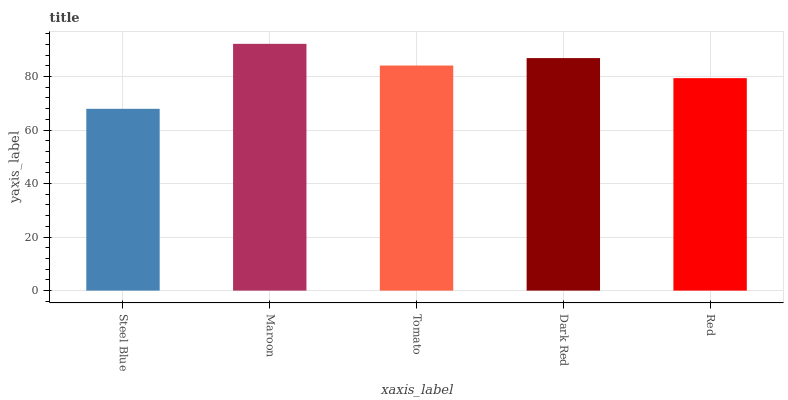Is Steel Blue the minimum?
Answer yes or no. Yes. Is Maroon the maximum?
Answer yes or no. Yes. Is Tomato the minimum?
Answer yes or no. No. Is Tomato the maximum?
Answer yes or no. No. Is Maroon greater than Tomato?
Answer yes or no. Yes. Is Tomato less than Maroon?
Answer yes or no. Yes. Is Tomato greater than Maroon?
Answer yes or no. No. Is Maroon less than Tomato?
Answer yes or no. No. Is Tomato the high median?
Answer yes or no. Yes. Is Tomato the low median?
Answer yes or no. Yes. Is Maroon the high median?
Answer yes or no. No. Is Red the low median?
Answer yes or no. No. 